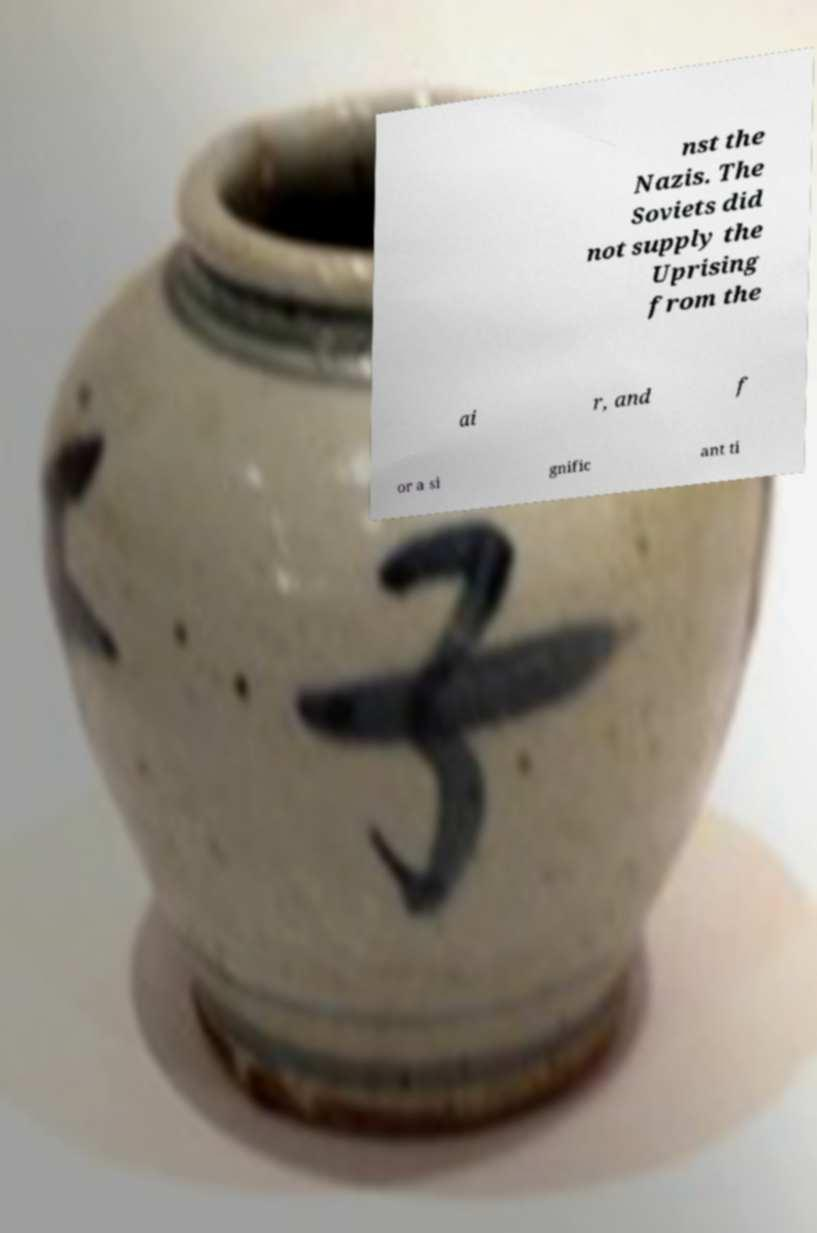Can you accurately transcribe the text from the provided image for me? nst the Nazis. The Soviets did not supply the Uprising from the ai r, and f or a si gnific ant ti 